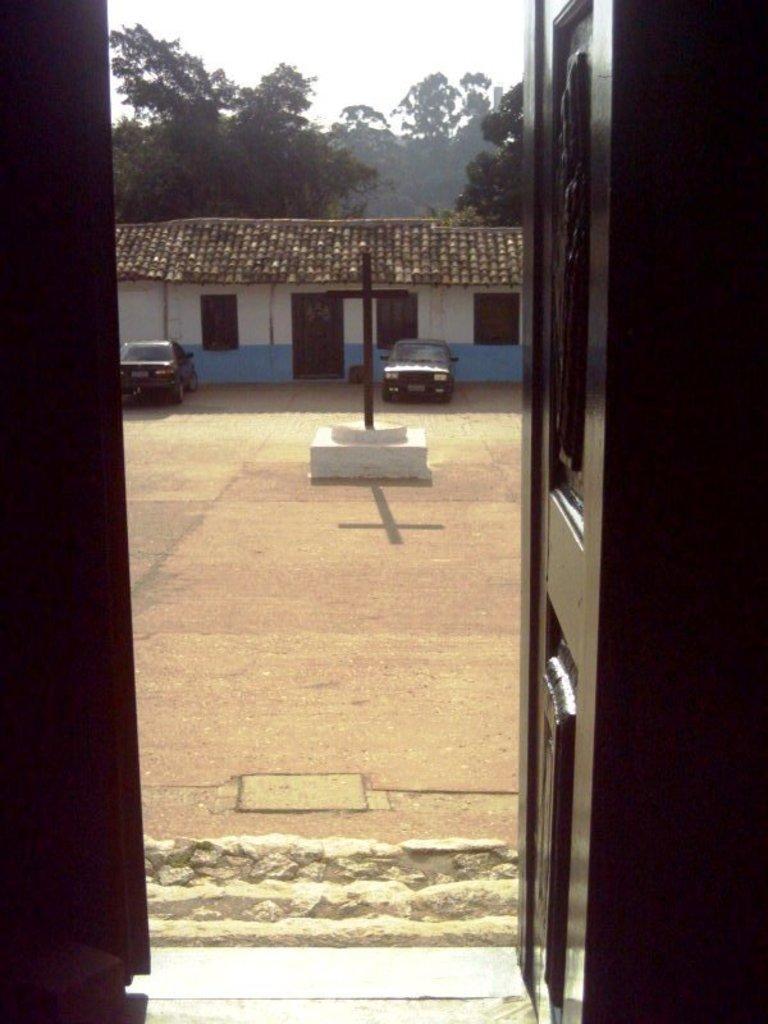In one or two sentences, can you explain what this image depicts? In this image we can see the door. Image also consists of a house, cars and a cross memorial on the ground. In the background we can see the trees. Sky is also visible. 